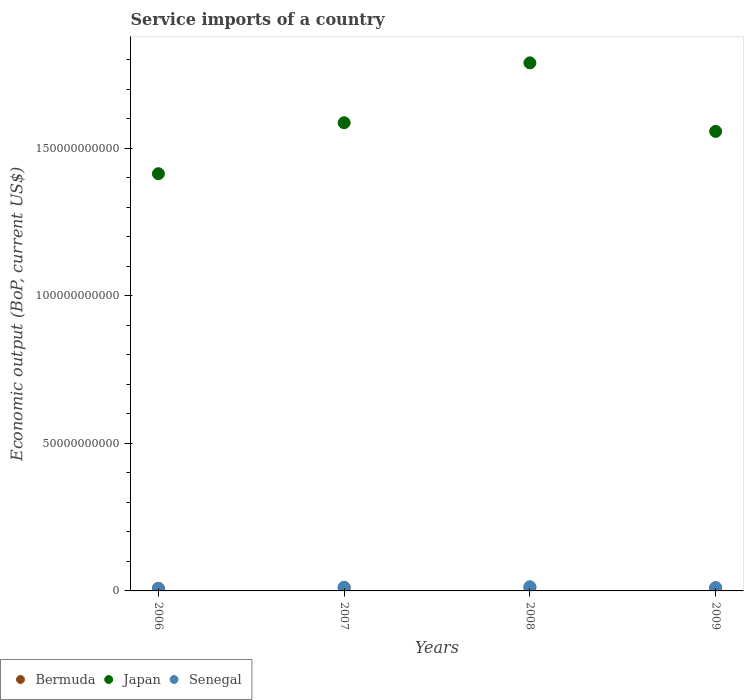Is the number of dotlines equal to the number of legend labels?
Make the answer very short. Yes. What is the service imports in Japan in 2006?
Provide a succinct answer. 1.41e+11. Across all years, what is the maximum service imports in Bermuda?
Offer a terse response. 1.12e+09. Across all years, what is the minimum service imports in Bermuda?
Your response must be concise. 8.62e+08. In which year was the service imports in Bermuda maximum?
Provide a succinct answer. 2007. What is the total service imports in Bermuda in the graph?
Your answer should be compact. 4.00e+09. What is the difference between the service imports in Japan in 2008 and that in 2009?
Your response must be concise. 2.32e+1. What is the difference between the service imports in Bermuda in 2008 and the service imports in Senegal in 2007?
Offer a terse response. -2.05e+08. What is the average service imports in Bermuda per year?
Give a very brief answer. 1.00e+09. In the year 2006, what is the difference between the service imports in Japan and service imports in Bermuda?
Your response must be concise. 1.41e+11. In how many years, is the service imports in Senegal greater than 120000000000 US$?
Your answer should be very brief. 0. What is the ratio of the service imports in Bermuda in 2007 to that in 2009?
Offer a terse response. 1.13. Is the service imports in Japan in 2007 less than that in 2009?
Provide a short and direct response. No. Is the difference between the service imports in Japan in 2007 and 2008 greater than the difference between the service imports in Bermuda in 2007 and 2008?
Ensure brevity in your answer.  No. What is the difference between the highest and the second highest service imports in Senegal?
Your answer should be very brief. 1.72e+08. What is the difference between the highest and the lowest service imports in Japan?
Keep it short and to the point. 3.76e+1. Is the sum of the service imports in Senegal in 2006 and 2008 greater than the maximum service imports in Bermuda across all years?
Make the answer very short. Yes. Does the service imports in Bermuda monotonically increase over the years?
Your answer should be compact. No. Are the values on the major ticks of Y-axis written in scientific E-notation?
Offer a terse response. No. Does the graph contain any zero values?
Make the answer very short. No. Where does the legend appear in the graph?
Keep it short and to the point. Bottom left. How are the legend labels stacked?
Offer a very short reply. Horizontal. What is the title of the graph?
Offer a very short reply. Service imports of a country. Does "Sierra Leone" appear as one of the legend labels in the graph?
Keep it short and to the point. No. What is the label or title of the X-axis?
Provide a succinct answer. Years. What is the label or title of the Y-axis?
Your response must be concise. Economic output (BoP, current US$). What is the Economic output (BoP, current US$) in Bermuda in 2006?
Keep it short and to the point. 8.62e+08. What is the Economic output (BoP, current US$) in Japan in 2006?
Your response must be concise. 1.41e+11. What is the Economic output (BoP, current US$) in Senegal in 2006?
Your response must be concise. 8.43e+08. What is the Economic output (BoP, current US$) in Bermuda in 2007?
Provide a short and direct response. 1.12e+09. What is the Economic output (BoP, current US$) of Japan in 2007?
Your answer should be very brief. 1.59e+11. What is the Economic output (BoP, current US$) of Senegal in 2007?
Your answer should be compact. 1.25e+09. What is the Economic output (BoP, current US$) of Bermuda in 2008?
Provide a short and direct response. 1.04e+09. What is the Economic output (BoP, current US$) of Japan in 2008?
Offer a terse response. 1.79e+11. What is the Economic output (BoP, current US$) in Senegal in 2008?
Offer a terse response. 1.42e+09. What is the Economic output (BoP, current US$) in Bermuda in 2009?
Your answer should be compact. 9.84e+08. What is the Economic output (BoP, current US$) in Japan in 2009?
Offer a terse response. 1.56e+11. What is the Economic output (BoP, current US$) in Senegal in 2009?
Offer a terse response. 1.15e+09. Across all years, what is the maximum Economic output (BoP, current US$) in Bermuda?
Make the answer very short. 1.12e+09. Across all years, what is the maximum Economic output (BoP, current US$) of Japan?
Your answer should be very brief. 1.79e+11. Across all years, what is the maximum Economic output (BoP, current US$) of Senegal?
Provide a succinct answer. 1.42e+09. Across all years, what is the minimum Economic output (BoP, current US$) of Bermuda?
Provide a short and direct response. 8.62e+08. Across all years, what is the minimum Economic output (BoP, current US$) of Japan?
Make the answer very short. 1.41e+11. Across all years, what is the minimum Economic output (BoP, current US$) in Senegal?
Your answer should be compact. 8.43e+08. What is the total Economic output (BoP, current US$) of Bermuda in the graph?
Keep it short and to the point. 4.00e+09. What is the total Economic output (BoP, current US$) in Japan in the graph?
Make the answer very short. 6.35e+11. What is the total Economic output (BoP, current US$) in Senegal in the graph?
Provide a succinct answer. 4.66e+09. What is the difference between the Economic output (BoP, current US$) in Bermuda in 2006 and that in 2007?
Provide a short and direct response. -2.53e+08. What is the difference between the Economic output (BoP, current US$) in Japan in 2006 and that in 2007?
Provide a short and direct response. -1.73e+1. What is the difference between the Economic output (BoP, current US$) of Senegal in 2006 and that in 2007?
Provide a short and direct response. -4.04e+08. What is the difference between the Economic output (BoP, current US$) of Bermuda in 2006 and that in 2008?
Your response must be concise. -1.80e+08. What is the difference between the Economic output (BoP, current US$) in Japan in 2006 and that in 2008?
Your answer should be compact. -3.76e+1. What is the difference between the Economic output (BoP, current US$) in Senegal in 2006 and that in 2008?
Keep it short and to the point. -5.76e+08. What is the difference between the Economic output (BoP, current US$) in Bermuda in 2006 and that in 2009?
Your answer should be compact. -1.22e+08. What is the difference between the Economic output (BoP, current US$) of Japan in 2006 and that in 2009?
Make the answer very short. -1.43e+1. What is the difference between the Economic output (BoP, current US$) in Senegal in 2006 and that in 2009?
Your answer should be very brief. -3.06e+08. What is the difference between the Economic output (BoP, current US$) of Bermuda in 2007 and that in 2008?
Offer a terse response. 7.37e+07. What is the difference between the Economic output (BoP, current US$) in Japan in 2007 and that in 2008?
Offer a terse response. -2.03e+1. What is the difference between the Economic output (BoP, current US$) in Senegal in 2007 and that in 2008?
Make the answer very short. -1.72e+08. What is the difference between the Economic output (BoP, current US$) of Bermuda in 2007 and that in 2009?
Offer a terse response. 1.31e+08. What is the difference between the Economic output (BoP, current US$) of Japan in 2007 and that in 2009?
Your answer should be compact. 2.92e+09. What is the difference between the Economic output (BoP, current US$) in Senegal in 2007 and that in 2009?
Provide a succinct answer. 9.76e+07. What is the difference between the Economic output (BoP, current US$) of Bermuda in 2008 and that in 2009?
Provide a short and direct response. 5.73e+07. What is the difference between the Economic output (BoP, current US$) of Japan in 2008 and that in 2009?
Ensure brevity in your answer.  2.32e+1. What is the difference between the Economic output (BoP, current US$) in Senegal in 2008 and that in 2009?
Make the answer very short. 2.70e+08. What is the difference between the Economic output (BoP, current US$) in Bermuda in 2006 and the Economic output (BoP, current US$) in Japan in 2007?
Provide a succinct answer. -1.58e+11. What is the difference between the Economic output (BoP, current US$) in Bermuda in 2006 and the Economic output (BoP, current US$) in Senegal in 2007?
Your response must be concise. -3.85e+08. What is the difference between the Economic output (BoP, current US$) of Japan in 2006 and the Economic output (BoP, current US$) of Senegal in 2007?
Provide a succinct answer. 1.40e+11. What is the difference between the Economic output (BoP, current US$) of Bermuda in 2006 and the Economic output (BoP, current US$) of Japan in 2008?
Give a very brief answer. -1.78e+11. What is the difference between the Economic output (BoP, current US$) of Bermuda in 2006 and the Economic output (BoP, current US$) of Senegal in 2008?
Make the answer very short. -5.57e+08. What is the difference between the Economic output (BoP, current US$) in Japan in 2006 and the Economic output (BoP, current US$) in Senegal in 2008?
Provide a short and direct response. 1.40e+11. What is the difference between the Economic output (BoP, current US$) of Bermuda in 2006 and the Economic output (BoP, current US$) of Japan in 2009?
Ensure brevity in your answer.  -1.55e+11. What is the difference between the Economic output (BoP, current US$) in Bermuda in 2006 and the Economic output (BoP, current US$) in Senegal in 2009?
Give a very brief answer. -2.87e+08. What is the difference between the Economic output (BoP, current US$) in Japan in 2006 and the Economic output (BoP, current US$) in Senegal in 2009?
Your answer should be compact. 1.40e+11. What is the difference between the Economic output (BoP, current US$) in Bermuda in 2007 and the Economic output (BoP, current US$) in Japan in 2008?
Offer a very short reply. -1.78e+11. What is the difference between the Economic output (BoP, current US$) of Bermuda in 2007 and the Economic output (BoP, current US$) of Senegal in 2008?
Ensure brevity in your answer.  -3.04e+08. What is the difference between the Economic output (BoP, current US$) of Japan in 2007 and the Economic output (BoP, current US$) of Senegal in 2008?
Ensure brevity in your answer.  1.57e+11. What is the difference between the Economic output (BoP, current US$) of Bermuda in 2007 and the Economic output (BoP, current US$) of Japan in 2009?
Offer a terse response. -1.55e+11. What is the difference between the Economic output (BoP, current US$) of Bermuda in 2007 and the Economic output (BoP, current US$) of Senegal in 2009?
Ensure brevity in your answer.  -3.38e+07. What is the difference between the Economic output (BoP, current US$) in Japan in 2007 and the Economic output (BoP, current US$) in Senegal in 2009?
Your answer should be very brief. 1.58e+11. What is the difference between the Economic output (BoP, current US$) of Bermuda in 2008 and the Economic output (BoP, current US$) of Japan in 2009?
Keep it short and to the point. -1.55e+11. What is the difference between the Economic output (BoP, current US$) in Bermuda in 2008 and the Economic output (BoP, current US$) in Senegal in 2009?
Offer a very short reply. -1.07e+08. What is the difference between the Economic output (BoP, current US$) in Japan in 2008 and the Economic output (BoP, current US$) in Senegal in 2009?
Provide a short and direct response. 1.78e+11. What is the average Economic output (BoP, current US$) of Bermuda per year?
Offer a very short reply. 1.00e+09. What is the average Economic output (BoP, current US$) of Japan per year?
Keep it short and to the point. 1.59e+11. What is the average Economic output (BoP, current US$) of Senegal per year?
Your answer should be very brief. 1.16e+09. In the year 2006, what is the difference between the Economic output (BoP, current US$) in Bermuda and Economic output (BoP, current US$) in Japan?
Keep it short and to the point. -1.41e+11. In the year 2006, what is the difference between the Economic output (BoP, current US$) in Bermuda and Economic output (BoP, current US$) in Senegal?
Provide a succinct answer. 1.93e+07. In the year 2006, what is the difference between the Economic output (BoP, current US$) in Japan and Economic output (BoP, current US$) in Senegal?
Give a very brief answer. 1.41e+11. In the year 2007, what is the difference between the Economic output (BoP, current US$) in Bermuda and Economic output (BoP, current US$) in Japan?
Your answer should be very brief. -1.58e+11. In the year 2007, what is the difference between the Economic output (BoP, current US$) in Bermuda and Economic output (BoP, current US$) in Senegal?
Offer a terse response. -1.31e+08. In the year 2007, what is the difference between the Economic output (BoP, current US$) of Japan and Economic output (BoP, current US$) of Senegal?
Your answer should be very brief. 1.57e+11. In the year 2008, what is the difference between the Economic output (BoP, current US$) in Bermuda and Economic output (BoP, current US$) in Japan?
Ensure brevity in your answer.  -1.78e+11. In the year 2008, what is the difference between the Economic output (BoP, current US$) of Bermuda and Economic output (BoP, current US$) of Senegal?
Your answer should be compact. -3.78e+08. In the year 2008, what is the difference between the Economic output (BoP, current US$) in Japan and Economic output (BoP, current US$) in Senegal?
Provide a short and direct response. 1.78e+11. In the year 2009, what is the difference between the Economic output (BoP, current US$) of Bermuda and Economic output (BoP, current US$) of Japan?
Ensure brevity in your answer.  -1.55e+11. In the year 2009, what is the difference between the Economic output (BoP, current US$) of Bermuda and Economic output (BoP, current US$) of Senegal?
Your answer should be compact. -1.65e+08. In the year 2009, what is the difference between the Economic output (BoP, current US$) of Japan and Economic output (BoP, current US$) of Senegal?
Your answer should be compact. 1.55e+11. What is the ratio of the Economic output (BoP, current US$) of Bermuda in 2006 to that in 2007?
Provide a short and direct response. 0.77. What is the ratio of the Economic output (BoP, current US$) in Japan in 2006 to that in 2007?
Your answer should be very brief. 0.89. What is the ratio of the Economic output (BoP, current US$) in Senegal in 2006 to that in 2007?
Provide a short and direct response. 0.68. What is the ratio of the Economic output (BoP, current US$) in Bermuda in 2006 to that in 2008?
Ensure brevity in your answer.  0.83. What is the ratio of the Economic output (BoP, current US$) of Japan in 2006 to that in 2008?
Your answer should be very brief. 0.79. What is the ratio of the Economic output (BoP, current US$) of Senegal in 2006 to that in 2008?
Offer a very short reply. 0.59. What is the ratio of the Economic output (BoP, current US$) in Bermuda in 2006 to that in 2009?
Keep it short and to the point. 0.88. What is the ratio of the Economic output (BoP, current US$) in Japan in 2006 to that in 2009?
Keep it short and to the point. 0.91. What is the ratio of the Economic output (BoP, current US$) in Senegal in 2006 to that in 2009?
Your response must be concise. 0.73. What is the ratio of the Economic output (BoP, current US$) in Bermuda in 2007 to that in 2008?
Keep it short and to the point. 1.07. What is the ratio of the Economic output (BoP, current US$) in Japan in 2007 to that in 2008?
Ensure brevity in your answer.  0.89. What is the ratio of the Economic output (BoP, current US$) in Senegal in 2007 to that in 2008?
Offer a very short reply. 0.88. What is the ratio of the Economic output (BoP, current US$) of Bermuda in 2007 to that in 2009?
Make the answer very short. 1.13. What is the ratio of the Economic output (BoP, current US$) in Japan in 2007 to that in 2009?
Make the answer very short. 1.02. What is the ratio of the Economic output (BoP, current US$) of Senegal in 2007 to that in 2009?
Offer a very short reply. 1.08. What is the ratio of the Economic output (BoP, current US$) in Bermuda in 2008 to that in 2009?
Your answer should be compact. 1.06. What is the ratio of the Economic output (BoP, current US$) of Japan in 2008 to that in 2009?
Your answer should be very brief. 1.15. What is the ratio of the Economic output (BoP, current US$) of Senegal in 2008 to that in 2009?
Your answer should be compact. 1.24. What is the difference between the highest and the second highest Economic output (BoP, current US$) of Bermuda?
Offer a terse response. 7.37e+07. What is the difference between the highest and the second highest Economic output (BoP, current US$) of Japan?
Ensure brevity in your answer.  2.03e+1. What is the difference between the highest and the second highest Economic output (BoP, current US$) in Senegal?
Ensure brevity in your answer.  1.72e+08. What is the difference between the highest and the lowest Economic output (BoP, current US$) of Bermuda?
Give a very brief answer. 2.53e+08. What is the difference between the highest and the lowest Economic output (BoP, current US$) of Japan?
Your response must be concise. 3.76e+1. What is the difference between the highest and the lowest Economic output (BoP, current US$) of Senegal?
Ensure brevity in your answer.  5.76e+08. 